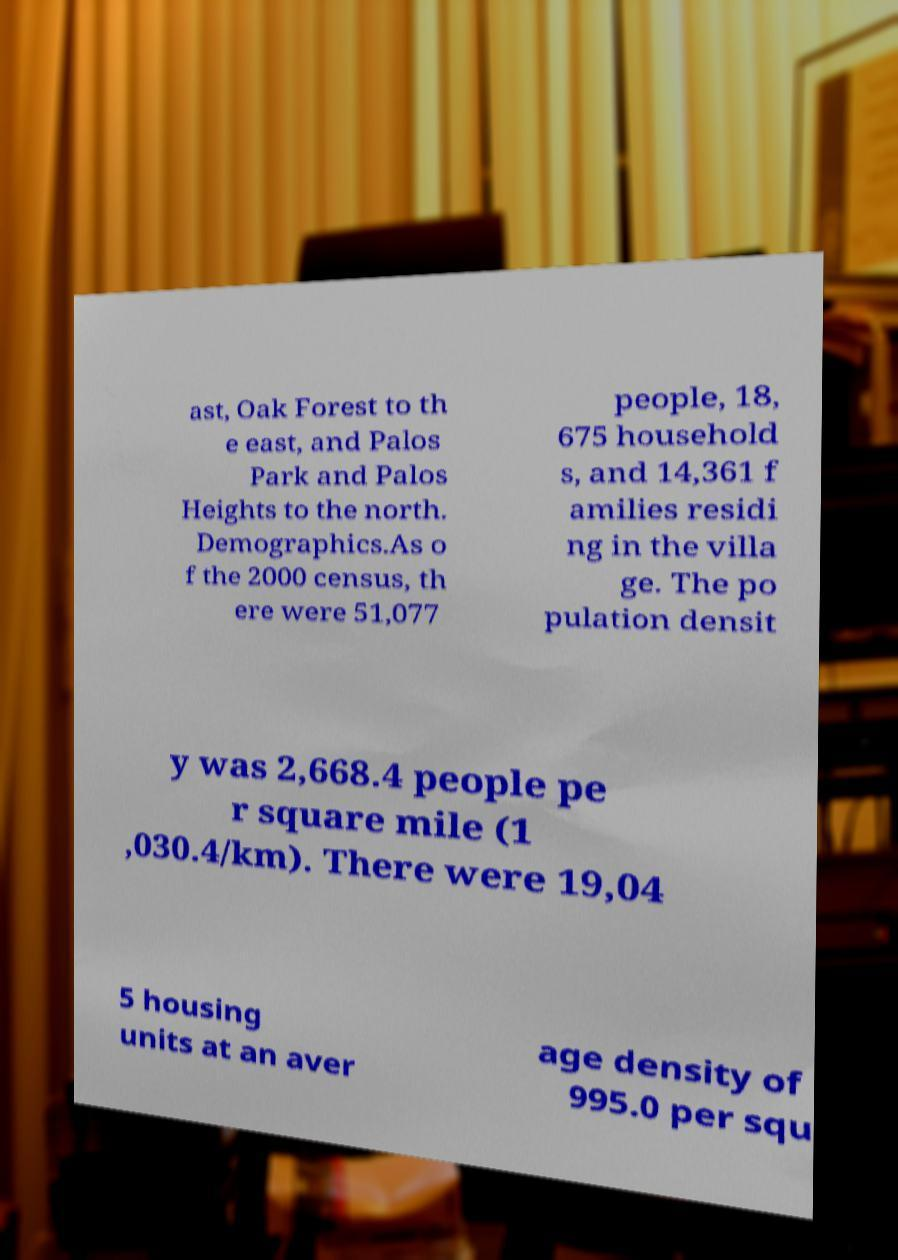Please identify and transcribe the text found in this image. ast, Oak Forest to th e east, and Palos Park and Palos Heights to the north. Demographics.As o f the 2000 census, th ere were 51,077 people, 18, 675 household s, and 14,361 f amilies residi ng in the villa ge. The po pulation densit y was 2,668.4 people pe r square mile (1 ,030.4/km). There were 19,04 5 housing units at an aver age density of 995.0 per squ 